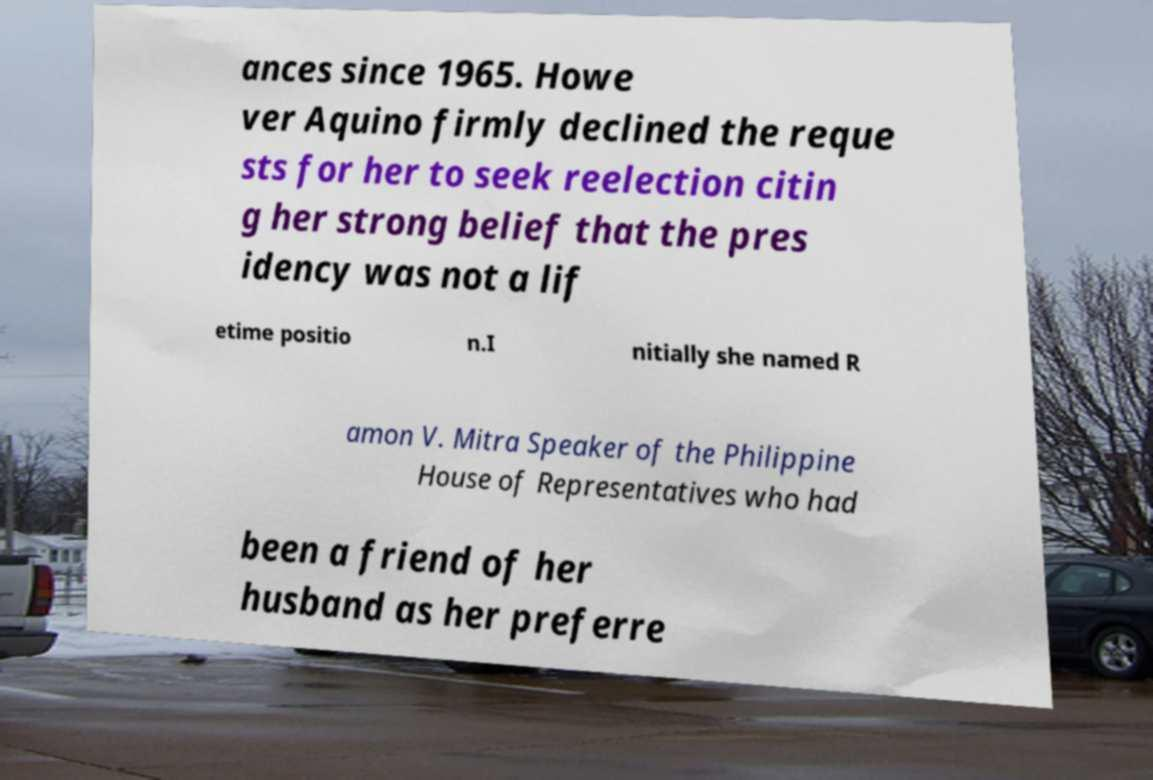Can you read and provide the text displayed in the image?This photo seems to have some interesting text. Can you extract and type it out for me? ances since 1965. Howe ver Aquino firmly declined the reque sts for her to seek reelection citin g her strong belief that the pres idency was not a lif etime positio n.I nitially she named R amon V. Mitra Speaker of the Philippine House of Representatives who had been a friend of her husband as her preferre 